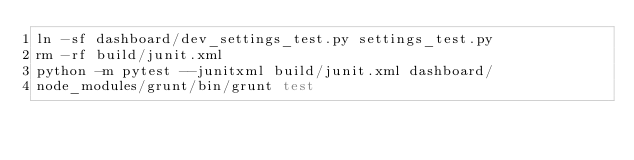Convert code to text. <code><loc_0><loc_0><loc_500><loc_500><_Bash_>ln -sf dashboard/dev_settings_test.py settings_test.py
rm -rf build/junit.xml
python -m pytest --junitxml build/junit.xml dashboard/
node_modules/grunt/bin/grunt test
</code> 